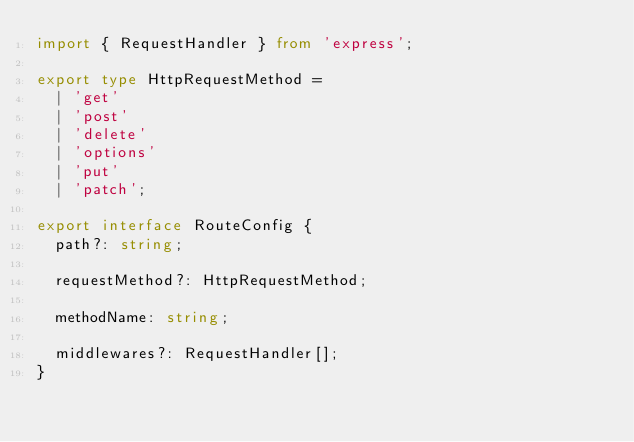Convert code to text. <code><loc_0><loc_0><loc_500><loc_500><_TypeScript_>import { RequestHandler } from 'express';

export type HttpRequestMethod =
  | 'get'
  | 'post'
  | 'delete'
  | 'options'
  | 'put'
  | 'patch';

export interface RouteConfig {
  path?: string;

  requestMethod?: HttpRequestMethod;

  methodName: string;

  middlewares?: RequestHandler[];
}
</code> 